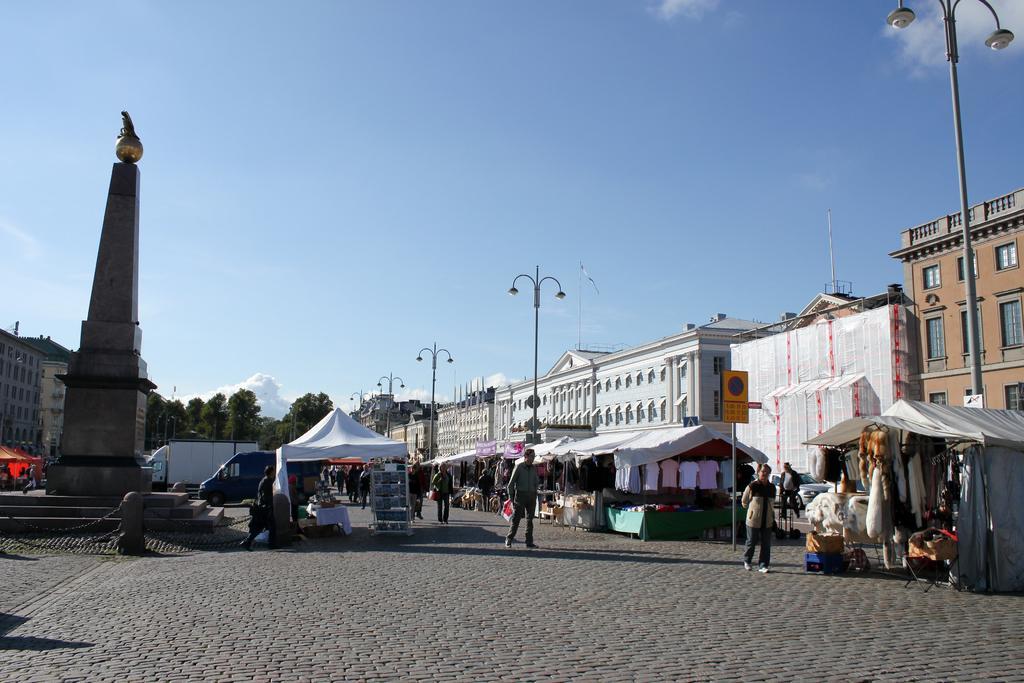In one or two sentences, can you explain what this image depicts? In this image there is a pillar on the left side. In the middle there is a tent. On the right side there are buildings. In front of the buildings there are tents under which there are stores. At the top there is the sky. There are light poles in between the tents. 